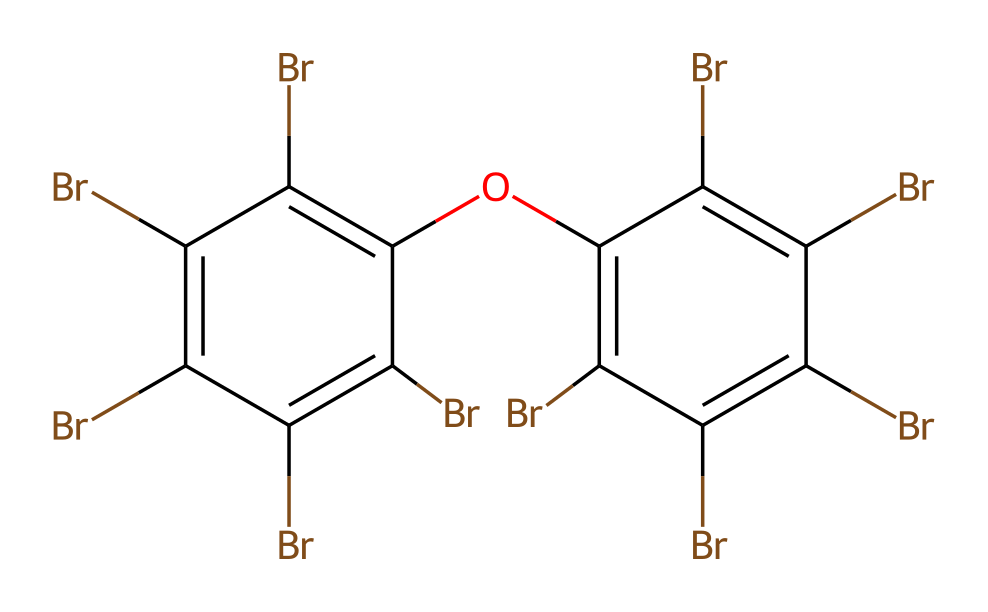what is the total number of bromine atoms in this chemical? By analyzing the SMILES representation, we can identify the number of bromine (Br) atoms. The structure contains six instances of the "Br" symbol, indicating that there are six bromine atoms present in the compound.
Answer: six how many oxygen atoms are in this chemical? In the provided SMILES representation, we look for the "O" symbol, which represents oxygen. There is one occurrence of "O" in the structure, indicating that there is one oxygen atom in the chemical.
Answer: one what functional group is present in this chemical? The structure includes a -O- linkage, represented by the "O" in the SMILES, connected to two aromatic carbons. This indicates the presence of an ether functional group within the chemical.
Answer: ether which elements are present in this chemical? By examining the SMILES notation, we can identify the elements based on their symbols: "Br" for bromine, "O" for oxygen, and the implicit carbon (C) atoms in the aromatic structure. Thus, the elements present are bromine and oxygen.
Answer: bromine and oxygen how many aromatic rings are present in this chemical? The SMILES shows two structural parts separated by an "Oc", which indicates a connection between two aromatic components. Each aromatic system can be recognized by its arrangement of alternating double bonds, leading to the conclusion that there are two aromatic rings present in the overall structure.
Answer: two is this chemical hydrophobic or hydrophilic? Given the high ratio of bromine atoms, which are typically hydrophobic due to their non-polar characteristics, combined with the presence of one oxygen that contributes to a slight hydrophilic nature, the overall property leans more toward hydrophobicity. Therefore, it is classified as a largely hydrophobic compound.
Answer: hydrophobic 